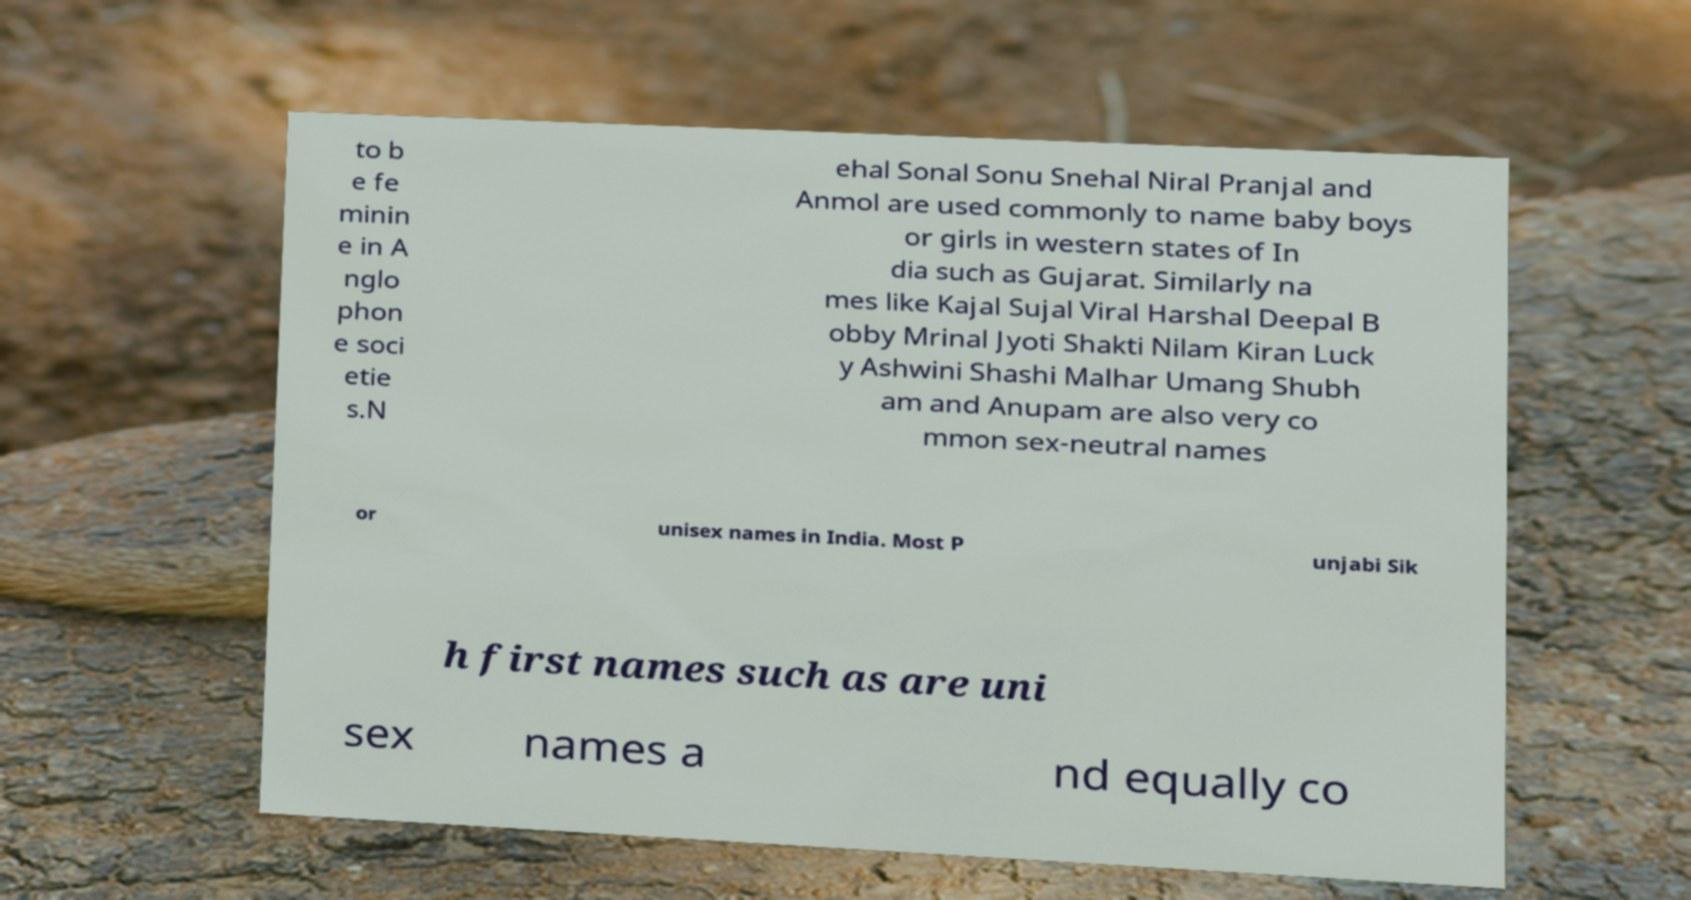What messages or text are displayed in this image? I need them in a readable, typed format. to b e fe minin e in A nglo phon e soci etie s.N ehal Sonal Sonu Snehal Niral Pranjal and Anmol are used commonly to name baby boys or girls in western states of In dia such as Gujarat. Similarly na mes like Kajal Sujal Viral Harshal Deepal B obby Mrinal Jyoti Shakti Nilam Kiran Luck y Ashwini Shashi Malhar Umang Shubh am and Anupam are also very co mmon sex-neutral names or unisex names in India. Most P unjabi Sik h first names such as are uni sex names a nd equally co 